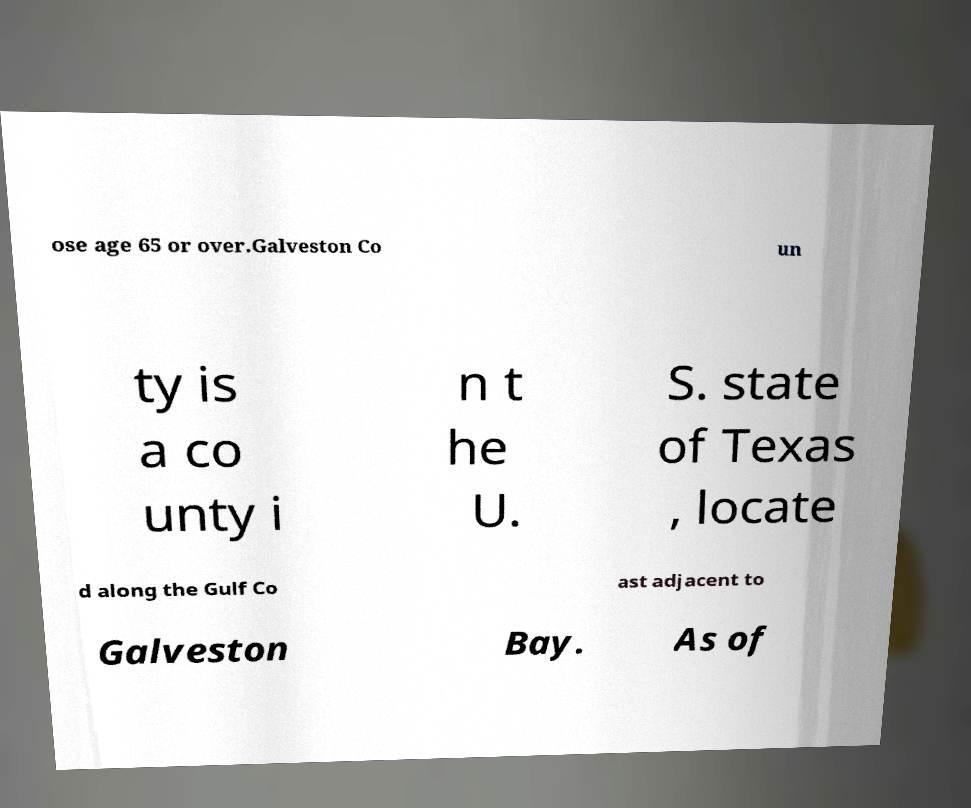Please identify and transcribe the text found in this image. ose age 65 or over.Galveston Co un ty is a co unty i n t he U. S. state of Texas , locate d along the Gulf Co ast adjacent to Galveston Bay. As of 